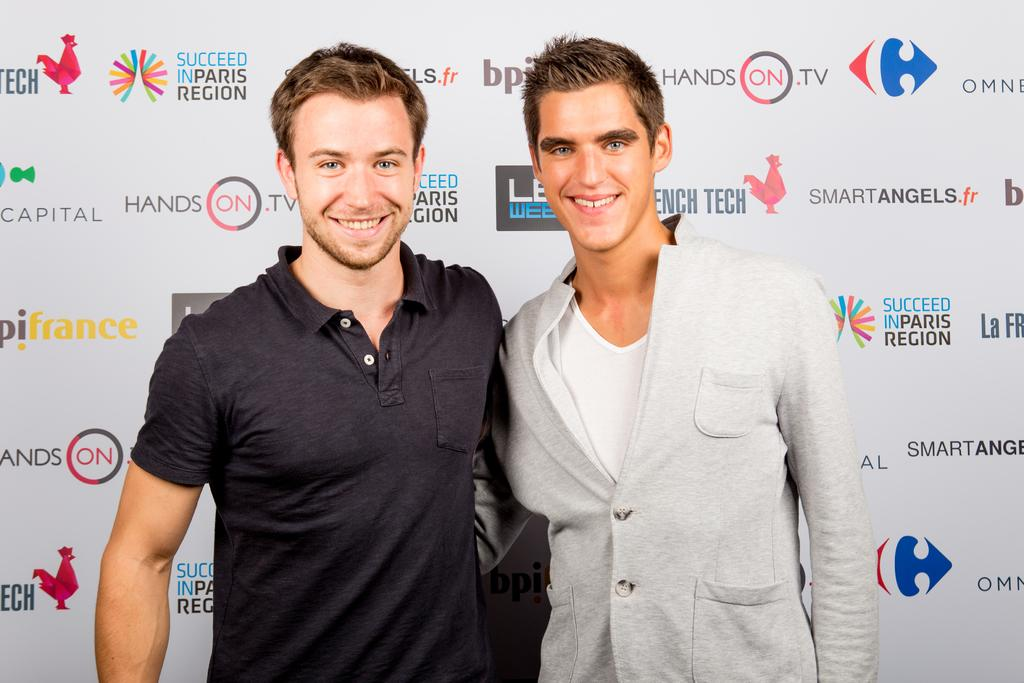How many people are present in the image? There are two people in the image. Can you describe the background of the image? There is a banner with text in the background of the image. What type of door can be seen in the image? There is no door present in the image; it only features two people and a banner with text in the background. 